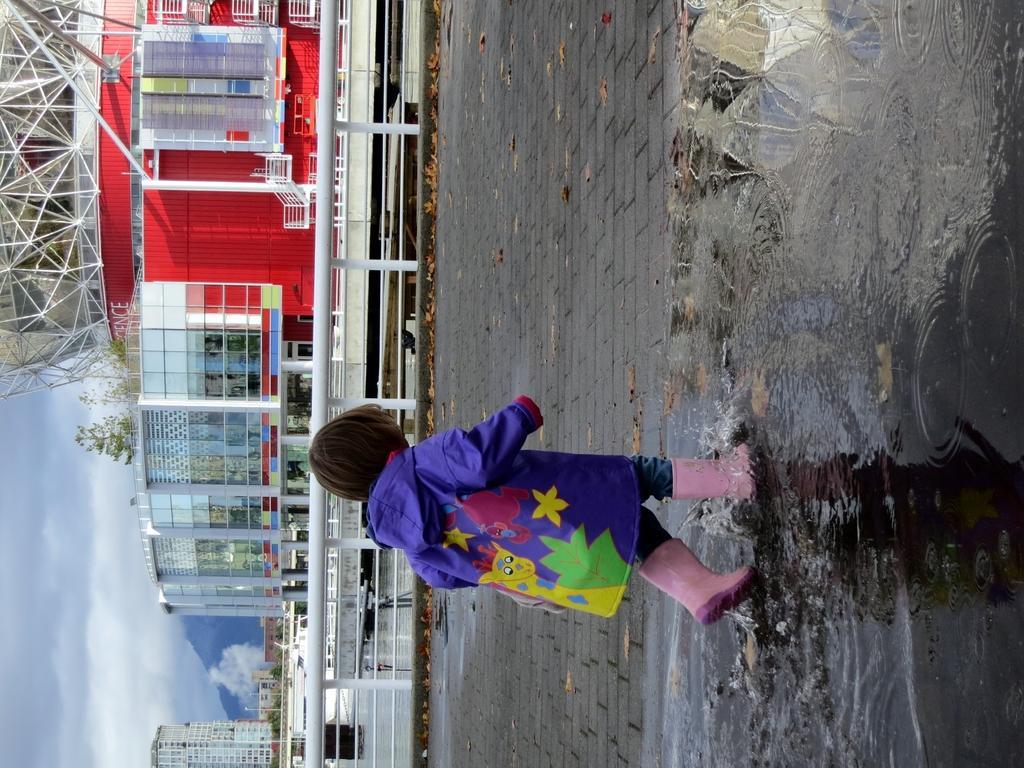Can you describe this image briefly? This image consists of a kid walking on the road. At the bottom, there is water. In the middle, there are buildings. And we can see a road. On the left, there are clouds in the sky. 